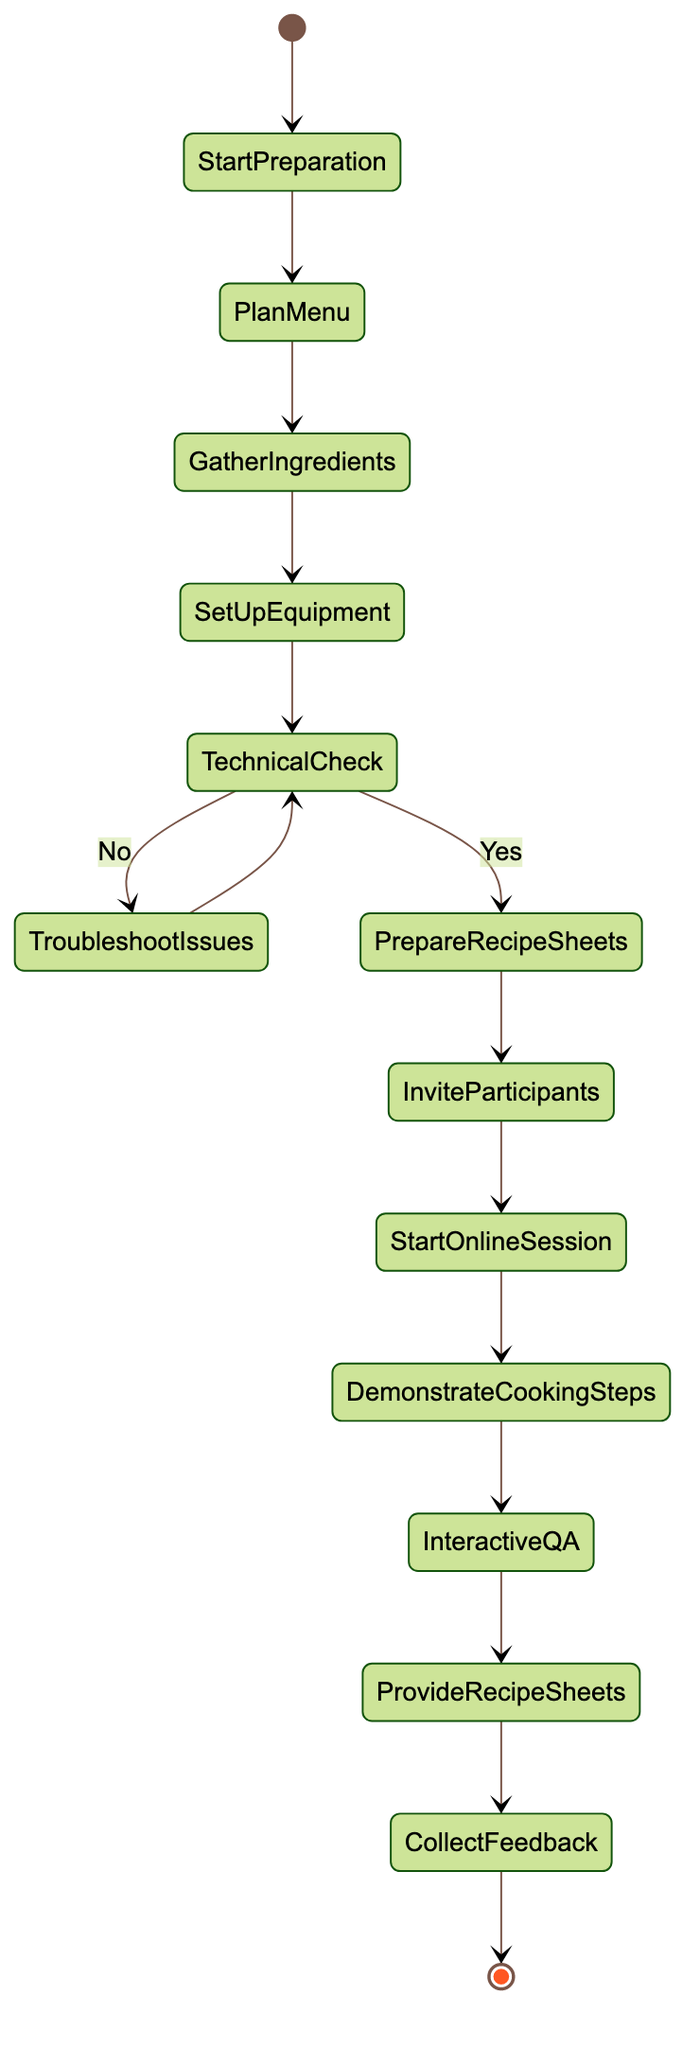What is the starting point of the diagram? The starting point is labeled as "Start Preparation", which indicates where the process begins in the activity diagram.
Answer: Start Preparation How many main actions are there in the diagram? By counting the action nodes, there are seven main actions, which are Plan Menu, Gather Ingredients, Set Up Equipment, Prepare Recipe Sheets, Invite Participants, Start Online Session, and Demonstrate Cooking Steps.
Answer: Seven What follows after the "Set Up Equipment" step? After the "Set Up Equipment" step, the next step is "Technical Check", which is the decision point determining the next course of action.
Answer: Technical Check What is the decision point in the diagram? The decision point is labeled "Technical Check", which requires a Yes or No response to proceed to different subsequent actions based on whether the question is answered affirmatively or negatively.
Answer: Technical Check If there are technical issues, which action is taken? If technical issues occur, the action taken is "Troubleshoot Issues", where the focus is on resolving problems related to technology used in the cooking class.
Answer: Troubleshoot Issues What happens if the technical check is successful? If the technical check is successful, the flow continues to the action "Prepare Recipe Sheets", indicating that the digital tools are working properly.
Answer: Prepare Recipe Sheets How does the session conclude? The session concludes with the action "Session End", which signifies the final step of the online cooking class after all previous steps have been completed.
Answer: Session End How does participant feedback fit into the diagram? Participant feedback is collected in the action titled "Collect Feedback", which is the last step before the "Session End", serving as a way to improve future classes.
Answer: Collect Feedback What is the primary purpose of the "Interactive Q&A" action? The primary purpose of the "Interactive Q&A" action is to engage with participants by answering their questions and providing additional cooking tips, thereby enhancing their learning experience.
Answer: Answer participant questions and offer tips 